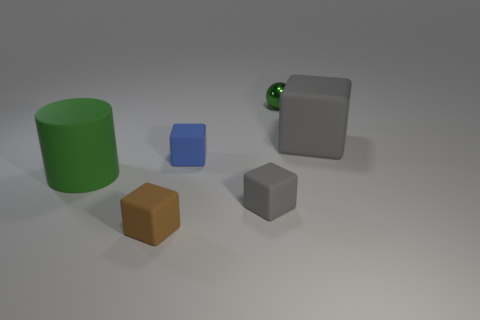Is there any other thing that has the same color as the tiny metallic thing?
Provide a short and direct response. Yes. What size is the blue cube that is made of the same material as the big green thing?
Give a very brief answer. Small. What material is the small brown block?
Keep it short and to the point. Rubber. What number of blue things have the same size as the ball?
Your response must be concise. 1. The tiny thing that is the same color as the big matte cylinder is what shape?
Give a very brief answer. Sphere. Are there any other green metal things of the same shape as the green metal object?
Keep it short and to the point. No. There is a ball that is the same size as the blue rubber thing; what is its color?
Ensure brevity in your answer.  Green. There is a tiny rubber thing behind the gray cube that is in front of the tiny blue rubber cube; what color is it?
Ensure brevity in your answer.  Blue. There is a block to the right of the tiny ball; is it the same color as the rubber cylinder?
Offer a very short reply. No. What shape is the large object on the left side of the matte block in front of the gray block that is to the left of the tiny metallic object?
Your answer should be very brief. Cylinder. 